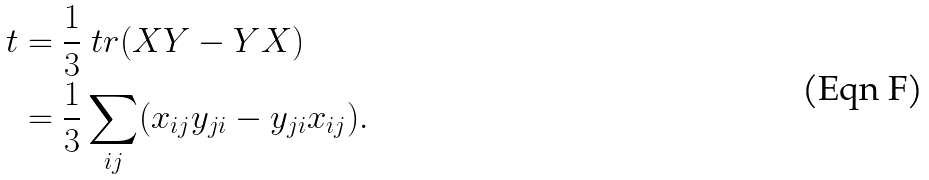<formula> <loc_0><loc_0><loc_500><loc_500>t & = \frac { 1 } { 3 } \ t r ( X Y - Y X ) \\ & = \frac { 1 } { 3 } \sum _ { i j } ( x _ { i j } y _ { j i } - y _ { j i } x _ { i j } ) .</formula> 